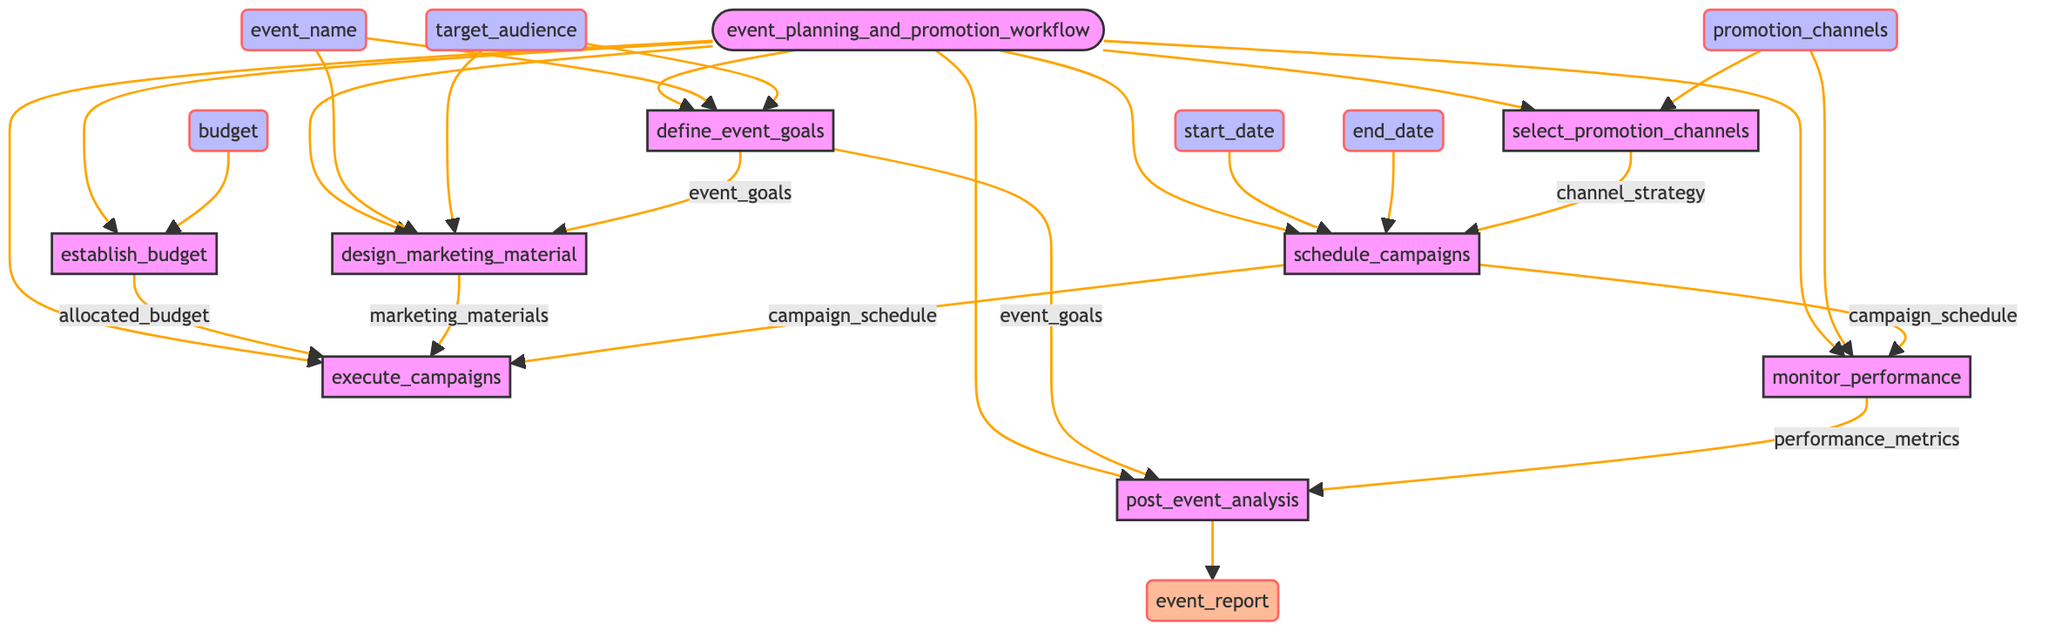What are the inputs for the function? The inputs for the function are event_name, start_date, end_date, target_audience, budget, and promotion_channels. These can be found at the top of the diagram.
Answer: event_name, start_date, end_date, target_audience, budget, promotion_channels How many steps are there in the process? The diagram outlines a total of eight steps, indicated by the nodes that represent each process in the workflow.
Answer: 8 What is the first step in the workflow? The first step in the workflow is to define event goals, as shown in the diagram where it is the first node leading from the function.
Answer: define_event_goals Which node connects to establish budget? The node that connects to establish budget is the budget input, as it leads directly to that step, indicating it is required to determine the budget.
Answer: budget What is the output of the post event analysis step? The output of the post event analysis step is the event report, which is listed as the final output of the entire workflow.
Answer: event_report How does one define event goals in the workflow? One defines event goals by taking inputs from event_name and target_audience. The connection is shown leading into this step with these two inputs.
Answer: event_name, target_audience How do marketing materials relate to the campaigns? Marketing materials are linked to the execute campaigns step, indicating that they are necessary inputs for carrying out the promotional campaigns based on the marketing plans.
Answer: marketing_materials What inputs are needed for scheduling campaigns? The inputs needed for scheduling campaigns are start_date, end_date, and channel_strategy, as these are the three connections shown leading into that step in the diagram.
Answer: start_date, end_date, channel_strategy What is required to monitor performance? To monitor performance, the inputs needed are campaign_schedule and promotion_channels, which guide the process that leads to tracking promotional efforts.
Answer: campaign_schedule, promotion_channels 